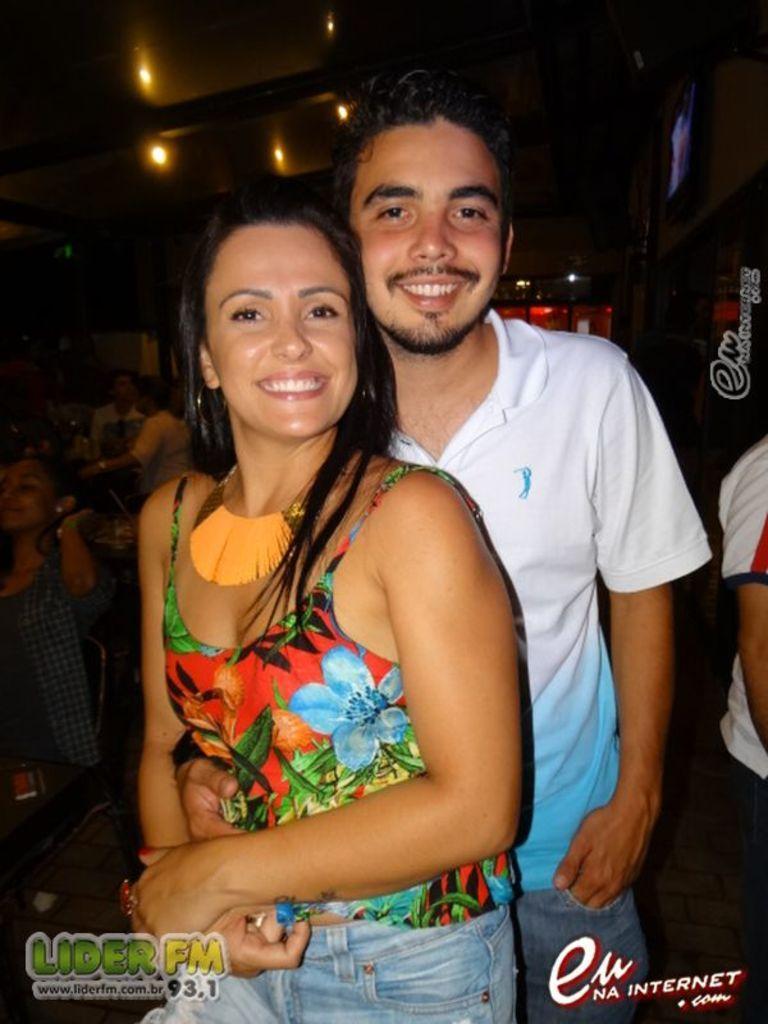Describe this image in one or two sentences. In this image, there are a few people. We can see some lights and a red colored object. We can also see a board. We can see some water marks on the right, bottom left corner and on the bottom right corner. 